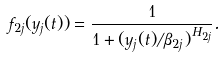Convert formula to latex. <formula><loc_0><loc_0><loc_500><loc_500>f _ { 2 j } ( y _ { j } ( t ) ) = \frac { 1 } { 1 + ( y _ { j } ( t ) / \beta _ { 2 j } ) ^ { H _ { 2 j } } } .</formula> 